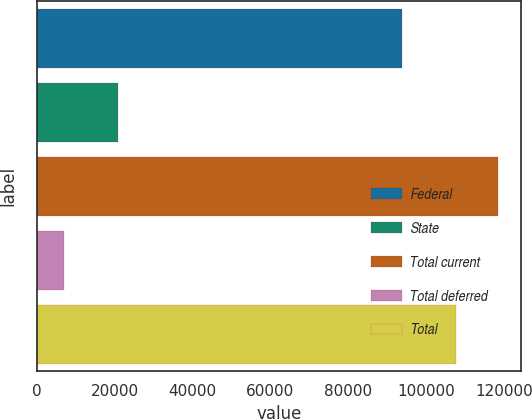Convert chart. <chart><loc_0><loc_0><loc_500><loc_500><bar_chart><fcel>Federal<fcel>State<fcel>Total current<fcel>Total deferred<fcel>Total<nl><fcel>93844<fcel>20958<fcel>118423<fcel>7145<fcel>107657<nl></chart> 